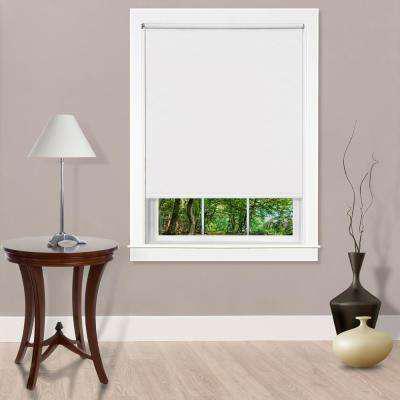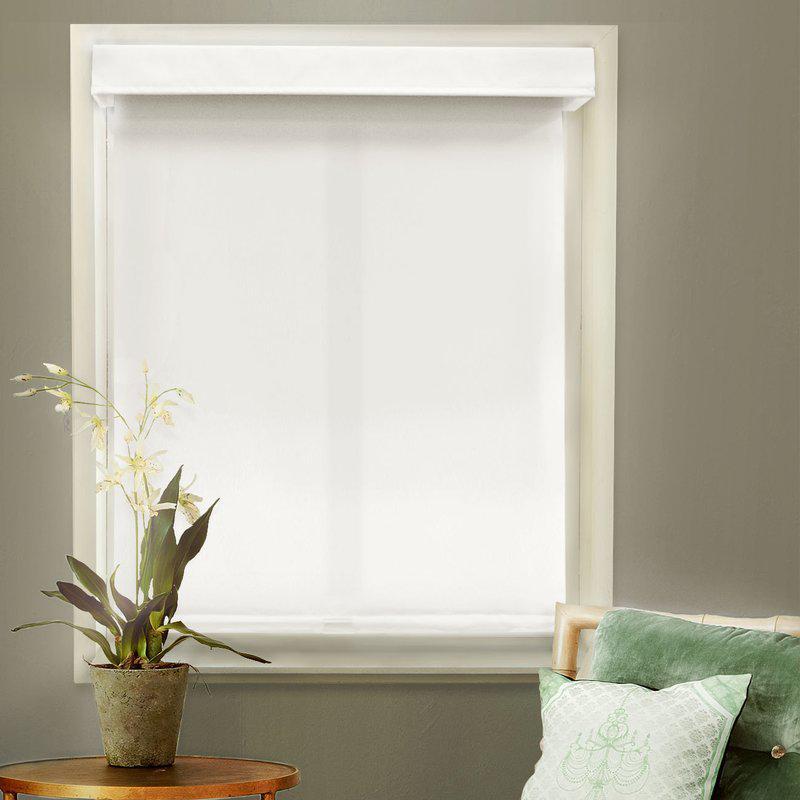The first image is the image on the left, the second image is the image on the right. Evaluate the accuracy of this statement regarding the images: "At least one window shade is completely closed.". Is it true? Answer yes or no. Yes. The first image is the image on the left, the second image is the image on the right. Given the left and right images, does the statement "There are three windows in a row that are on the same wall." hold true? Answer yes or no. No. 